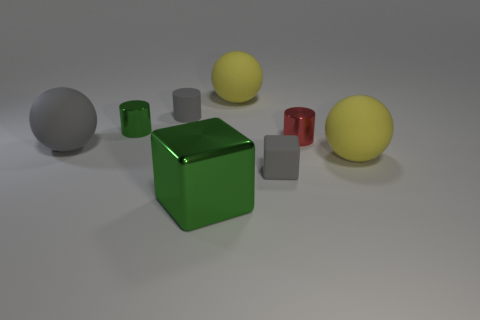Add 1 big red cylinders. How many objects exist? 9 Subtract all blocks. How many objects are left? 6 Add 6 tiny cylinders. How many tiny cylinders are left? 9 Add 2 green metal things. How many green metal things exist? 4 Subtract 1 green blocks. How many objects are left? 7 Subtract all tiny matte objects. Subtract all red things. How many objects are left? 5 